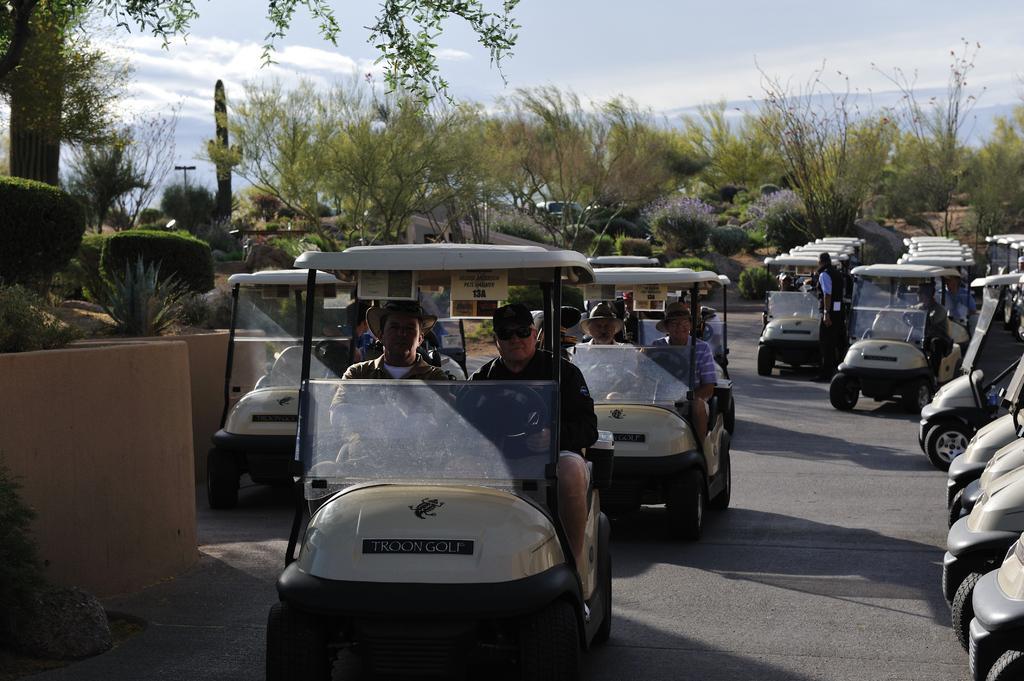Describe this image in one or two sentences. In this picture, we see many people riding many vehicles. Beside them, there are trees and shrubs. There are trees in the background. At the top of the picture, we see the sky. 